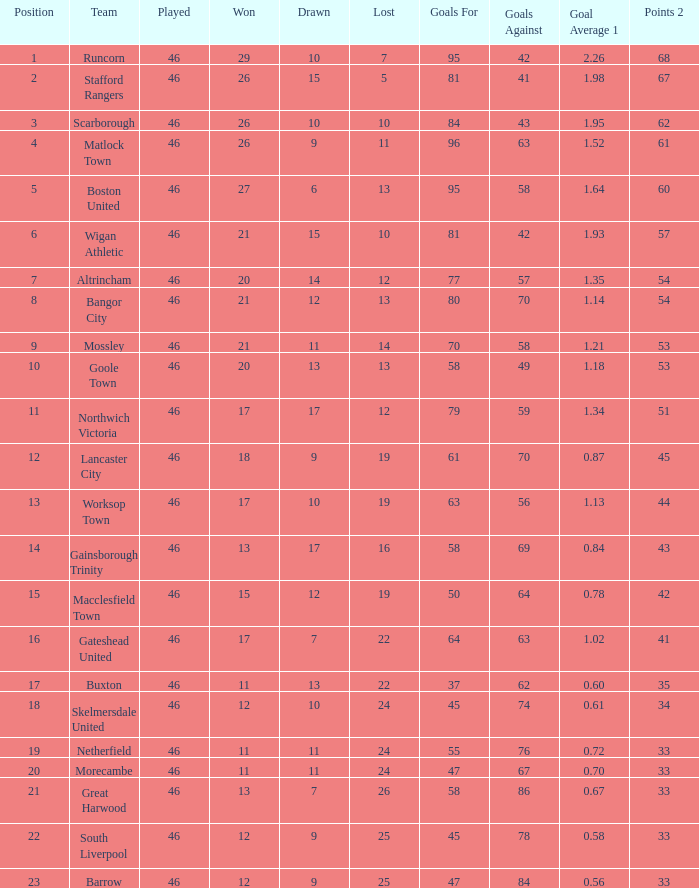Which team had goal averages of 1.34? Northwich Victoria. 